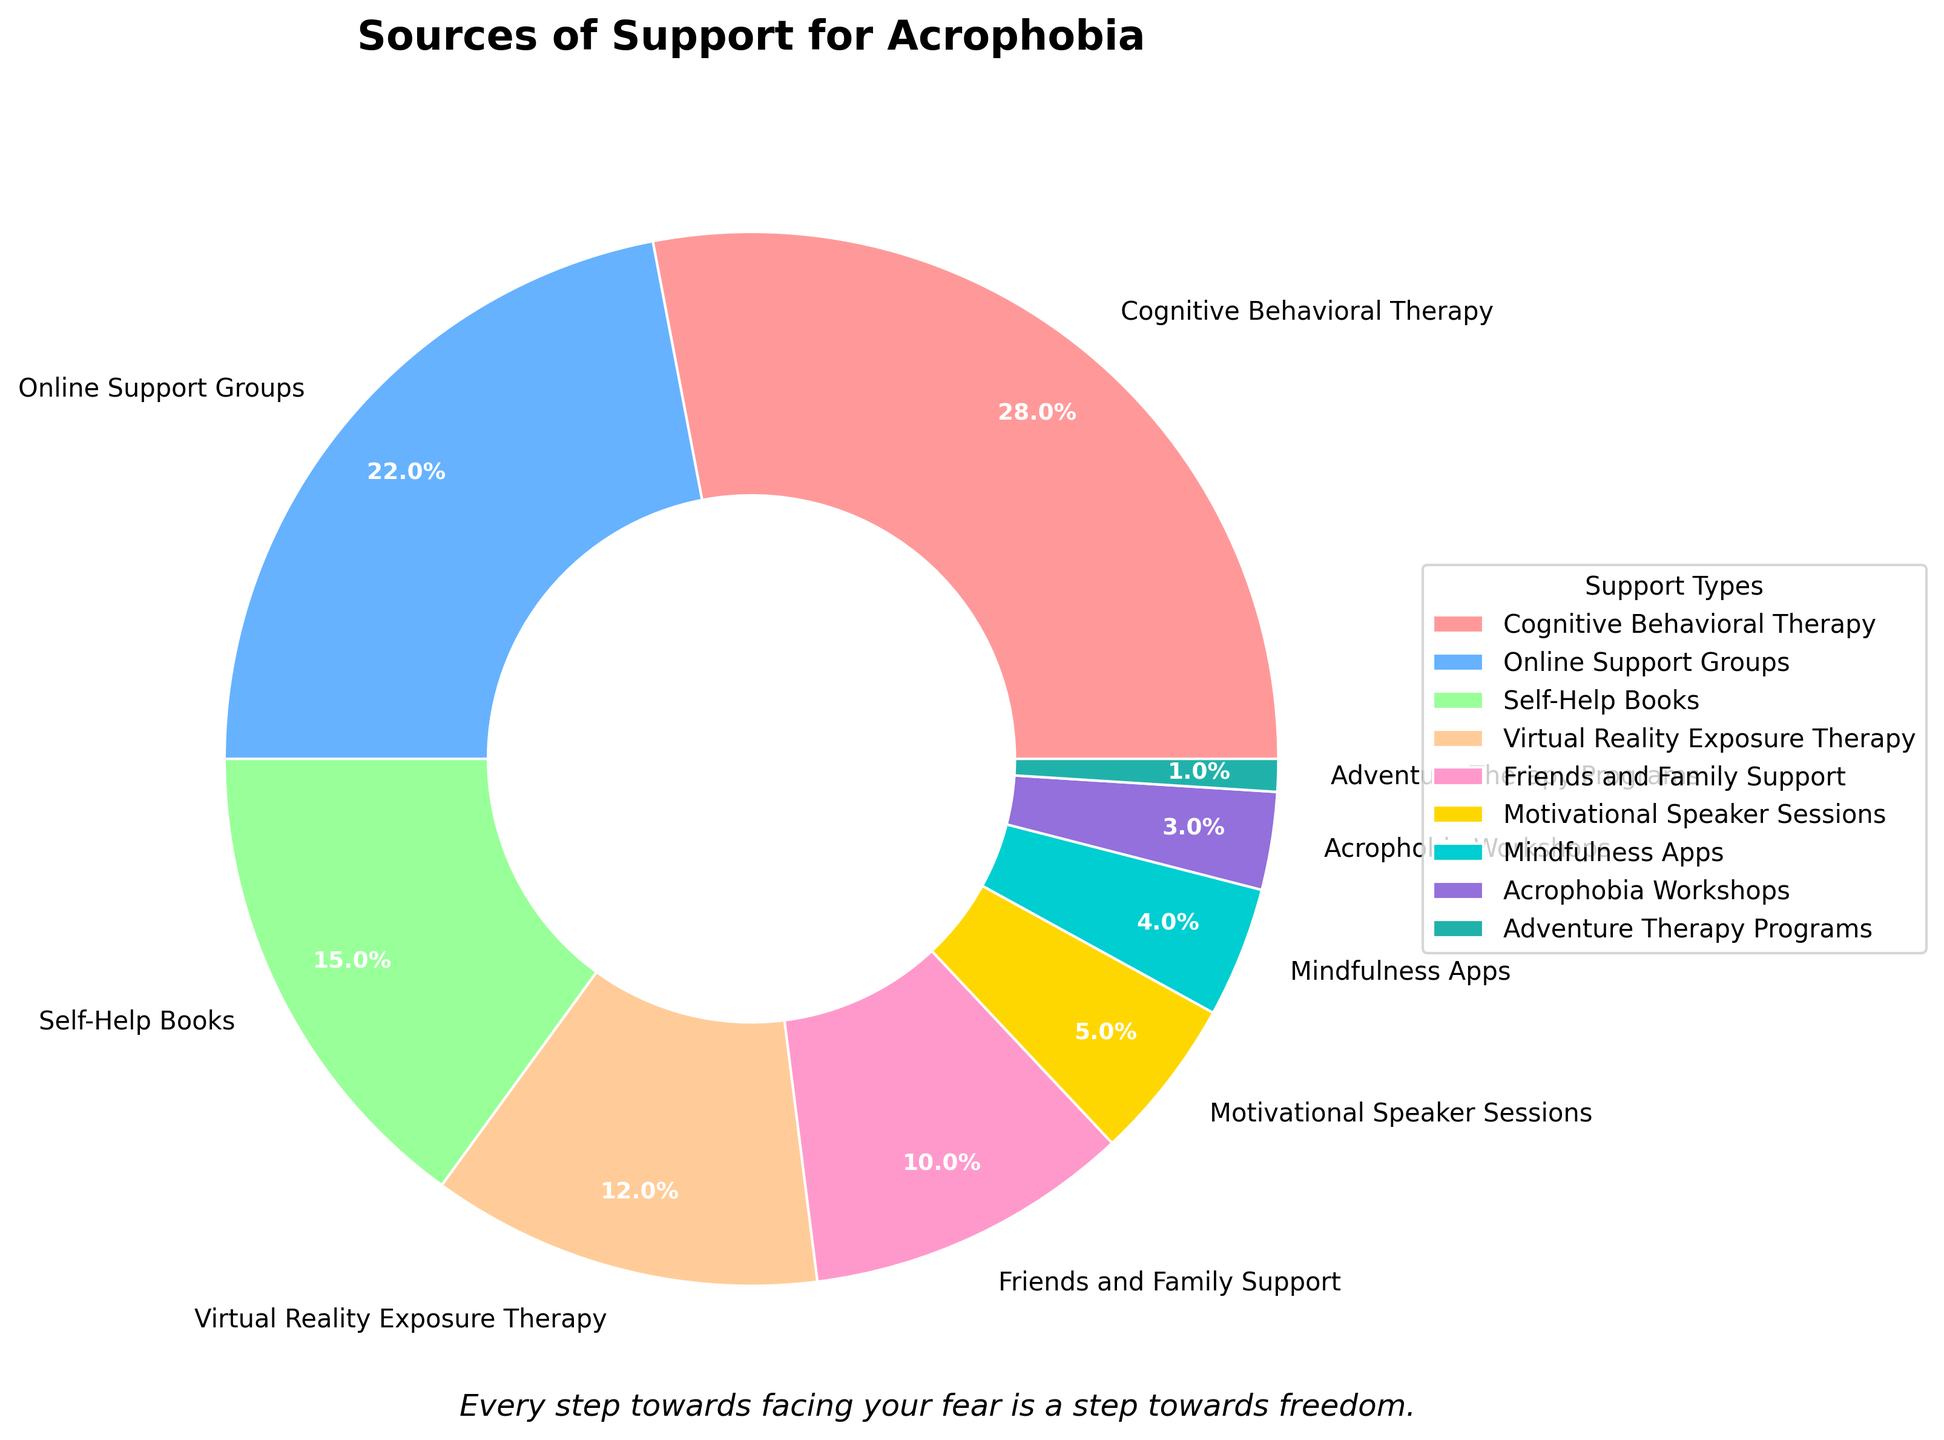What is the most utilized source of support for individuals with acrophobia? The figure shows various sources of support represented by slices of a pie chart. The largest slice, which occupies the most space, corresponds to Cognitive Behavioral Therapy.
Answer: Cognitive Behavioral Therapy Which source of support is utilized less than Online Support Groups but more than Motivational Speaker Sessions? By observing the sizes of the slices, the pie chart shows that Online Support Groups have a percentage of 22%, and Motivational Speaker Sessions have 5%. The slice for Self-Help Books fits between these percentages.
Answer: Self-Help Books How much more popular is Cognitive Behavioral Therapy compared to Adventure Therapy Programs? According to the pie chart, Cognitive Behavioral Therapy is 28% and Adventure Therapy Programs is 1%. The difference is calculated as 28 - 1 = 27.
Answer: 27% What is the combined percentage of Virtual Reality Exposure Therapy and Friends and Family Support? The figure shows that Virtual Reality Exposure Therapy is 12% and Friends and Family Support is 10%. Adding these together results in 12 + 10 = 22%.
Answer: 22% Which sources of support have percentages that add up to 10%? The chart segments reveal that Motivational Speaker Sessions have 5%, Mindfulness Apps have 4%, and Acrophobia Workshops have 3%. Adding any two of these exceeds 10%, but just the Motivational Speaker Sessions and Mindfulness Apps together equal 5 + 4 = 9%, which is close but not exact. Rechecking segments reveals that using "Adventure Therapy Programs (1%)" and the next smallest "Acrophobia Workshops (3%)" still doesn't sum to 10%. Thus, a logical conclusion conflated from smaller segments implies checking that none fitting exact 10%.
Answer: None Identify the source of support labeled with the light blue color and what percentage it represents. From the visual attributes of the pie chart, one of the slices is colored light blue, and it represents Online Support Groups. The percentage mentioned is 22%.
Answer: Online Support Groups, 22% What is the total percentage of support sources that are less than 10% each? The figure includes the sources: Motivational Speaker Sessions (5%), Mindfulness Apps (4%), Acrophobia Workshops (3%), and Adventure Therapy Programs (1%). Summing these percentages: 5 + 4 + 3 + 1 = 13%.
Answer: 13% Which source receives exactly half the support percentage compared to Cognitive Behavioral Therapy? Cognitive Behavioral Therapy is represented as 28%. Half of 28 is 28 / 2 = 14. Comparing this to the chart, no source exactly fits 14%; thus there is no exact half discrepancy. Rechecking confirms half inaccurate match.
Answer: None What message is written as a motivational quote on the figure? The title on the pie chart suggests support types for acrophobia, and below, the motivational quote is placed, stating, "Every step towards facing your fear is a step towards freedom."
Answer: Every step towards facing your fear is a step towards freedom 